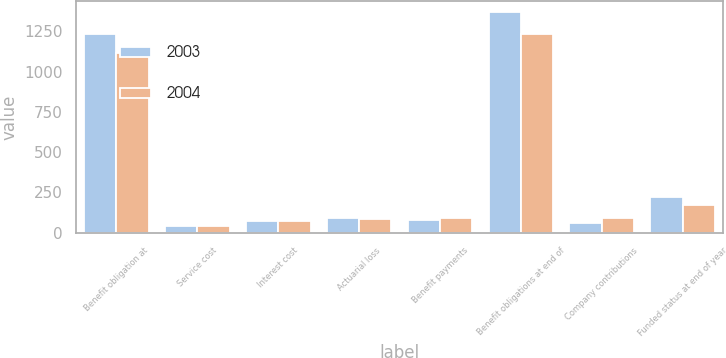Convert chart to OTSL. <chart><loc_0><loc_0><loc_500><loc_500><stacked_bar_chart><ecel><fcel>Benefit obligation at<fcel>Service cost<fcel>Interest cost<fcel>Actuarial loss<fcel>Benefit payments<fcel>Benefit obligations at end of<fcel>Company contributions<fcel>Funded status at end of year<nl><fcel>2003<fcel>1232.4<fcel>43.8<fcel>75.7<fcel>93<fcel>79.3<fcel>1368.3<fcel>62.6<fcel>220.1<nl><fcel>2004<fcel>1116.3<fcel>39.4<fcel>74.5<fcel>87.7<fcel>88.2<fcel>1232.4<fcel>92.6<fcel>172.8<nl></chart> 